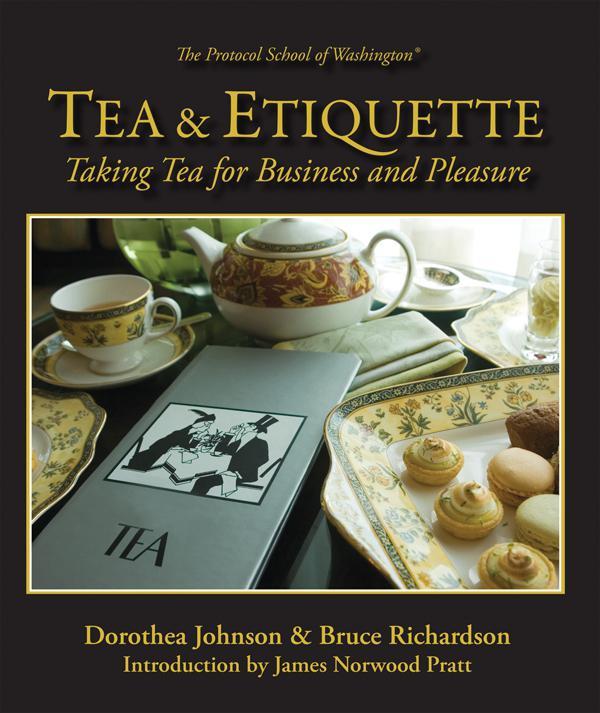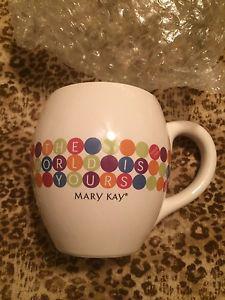The first image is the image on the left, the second image is the image on the right. Examine the images to the left and right. Is the description "In at least one image there is a single white cup of coffee on a plate that is all sitting on brown wooden table." accurate? Answer yes or no. No. The first image is the image on the left, the second image is the image on the right. Given the left and right images, does the statement "All the cups are solid white." hold true? Answer yes or no. No. 